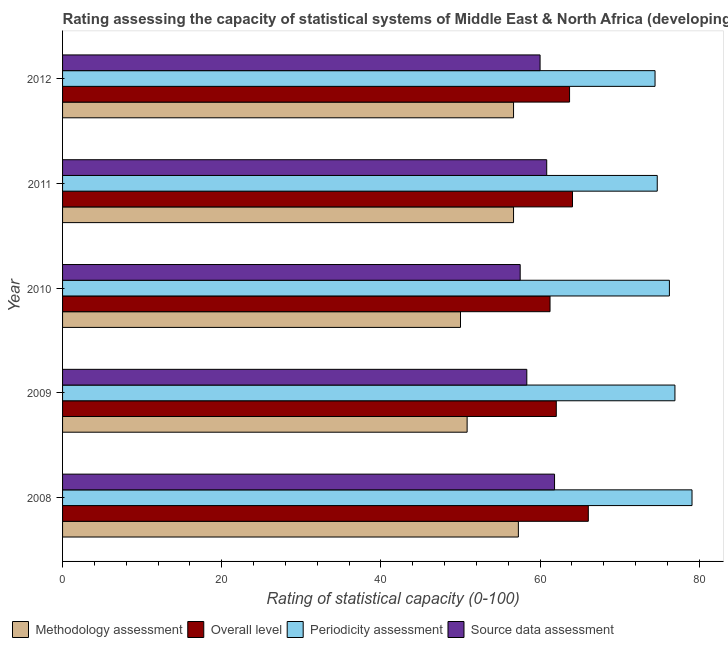How many different coloured bars are there?
Your answer should be compact. 4. How many groups of bars are there?
Make the answer very short. 5. Are the number of bars on each tick of the Y-axis equal?
Your response must be concise. Yes. How many bars are there on the 5th tick from the bottom?
Offer a very short reply. 4. What is the periodicity assessment rating in 2009?
Provide a short and direct response. 76.94. Across all years, what is the maximum periodicity assessment rating?
Your answer should be compact. 79.09. Across all years, what is the minimum periodicity assessment rating?
Provide a succinct answer. 74.44. In which year was the periodicity assessment rating minimum?
Your response must be concise. 2012. What is the total periodicity assessment rating in the graph?
Offer a terse response. 381.45. What is the difference between the source data assessment rating in 2008 and that in 2009?
Your response must be concise. 3.48. What is the difference between the source data assessment rating in 2010 and the methodology assessment rating in 2009?
Provide a short and direct response. 6.67. What is the average overall level rating per year?
Provide a short and direct response. 63.42. In the year 2011, what is the difference between the overall level rating and source data assessment rating?
Your response must be concise. 3.24. What is the ratio of the periodicity assessment rating in 2010 to that in 2012?
Ensure brevity in your answer.  1.02. Is the difference between the overall level rating in 2008 and 2009 greater than the difference between the source data assessment rating in 2008 and 2009?
Your answer should be compact. Yes. What is the difference between the highest and the second highest overall level rating?
Provide a succinct answer. 1.99. What is the difference between the highest and the lowest methodology assessment rating?
Provide a short and direct response. 7.27. In how many years, is the overall level rating greater than the average overall level rating taken over all years?
Offer a very short reply. 3. Is the sum of the source data assessment rating in 2008 and 2009 greater than the maximum overall level rating across all years?
Your answer should be compact. Yes. Is it the case that in every year, the sum of the overall level rating and source data assessment rating is greater than the sum of periodicity assessment rating and methodology assessment rating?
Provide a short and direct response. No. What does the 1st bar from the top in 2008 represents?
Ensure brevity in your answer.  Source data assessment. What does the 4th bar from the bottom in 2008 represents?
Ensure brevity in your answer.  Source data assessment. Are all the bars in the graph horizontal?
Give a very brief answer. Yes. How many years are there in the graph?
Your answer should be very brief. 5. Are the values on the major ticks of X-axis written in scientific E-notation?
Ensure brevity in your answer.  No. Does the graph contain any zero values?
Offer a very short reply. No. Does the graph contain grids?
Keep it short and to the point. No. Where does the legend appear in the graph?
Your answer should be very brief. Bottom left. How many legend labels are there?
Keep it short and to the point. 4. How are the legend labels stacked?
Your answer should be very brief. Horizontal. What is the title of the graph?
Make the answer very short. Rating assessing the capacity of statistical systems of Middle East & North Africa (developing only). What is the label or title of the X-axis?
Give a very brief answer. Rating of statistical capacity (0-100). What is the label or title of the Y-axis?
Offer a terse response. Year. What is the Rating of statistical capacity (0-100) in Methodology assessment in 2008?
Provide a short and direct response. 57.27. What is the Rating of statistical capacity (0-100) in Overall level in 2008?
Your response must be concise. 66.06. What is the Rating of statistical capacity (0-100) of Periodicity assessment in 2008?
Your answer should be very brief. 79.09. What is the Rating of statistical capacity (0-100) of Source data assessment in 2008?
Offer a very short reply. 61.82. What is the Rating of statistical capacity (0-100) in Methodology assessment in 2009?
Your answer should be compact. 50.83. What is the Rating of statistical capacity (0-100) of Overall level in 2009?
Your answer should be compact. 62.04. What is the Rating of statistical capacity (0-100) of Periodicity assessment in 2009?
Give a very brief answer. 76.94. What is the Rating of statistical capacity (0-100) in Source data assessment in 2009?
Offer a terse response. 58.33. What is the Rating of statistical capacity (0-100) in Methodology assessment in 2010?
Ensure brevity in your answer.  50. What is the Rating of statistical capacity (0-100) in Overall level in 2010?
Your response must be concise. 61.25. What is the Rating of statistical capacity (0-100) in Periodicity assessment in 2010?
Offer a terse response. 76.25. What is the Rating of statistical capacity (0-100) in Source data assessment in 2010?
Your answer should be compact. 57.5. What is the Rating of statistical capacity (0-100) in Methodology assessment in 2011?
Your answer should be compact. 56.67. What is the Rating of statistical capacity (0-100) in Overall level in 2011?
Your response must be concise. 64.07. What is the Rating of statistical capacity (0-100) in Periodicity assessment in 2011?
Keep it short and to the point. 74.72. What is the Rating of statistical capacity (0-100) in Source data assessment in 2011?
Give a very brief answer. 60.83. What is the Rating of statistical capacity (0-100) of Methodology assessment in 2012?
Provide a succinct answer. 56.67. What is the Rating of statistical capacity (0-100) in Overall level in 2012?
Your answer should be very brief. 63.7. What is the Rating of statistical capacity (0-100) of Periodicity assessment in 2012?
Ensure brevity in your answer.  74.44. What is the Rating of statistical capacity (0-100) of Source data assessment in 2012?
Provide a succinct answer. 60. Across all years, what is the maximum Rating of statistical capacity (0-100) of Methodology assessment?
Make the answer very short. 57.27. Across all years, what is the maximum Rating of statistical capacity (0-100) of Overall level?
Ensure brevity in your answer.  66.06. Across all years, what is the maximum Rating of statistical capacity (0-100) in Periodicity assessment?
Give a very brief answer. 79.09. Across all years, what is the maximum Rating of statistical capacity (0-100) of Source data assessment?
Provide a short and direct response. 61.82. Across all years, what is the minimum Rating of statistical capacity (0-100) of Methodology assessment?
Provide a succinct answer. 50. Across all years, what is the minimum Rating of statistical capacity (0-100) of Overall level?
Provide a succinct answer. 61.25. Across all years, what is the minimum Rating of statistical capacity (0-100) of Periodicity assessment?
Ensure brevity in your answer.  74.44. Across all years, what is the minimum Rating of statistical capacity (0-100) in Source data assessment?
Your answer should be very brief. 57.5. What is the total Rating of statistical capacity (0-100) of Methodology assessment in the graph?
Provide a succinct answer. 271.44. What is the total Rating of statistical capacity (0-100) of Overall level in the graph?
Make the answer very short. 317.13. What is the total Rating of statistical capacity (0-100) in Periodicity assessment in the graph?
Your answer should be compact. 381.45. What is the total Rating of statistical capacity (0-100) of Source data assessment in the graph?
Your response must be concise. 298.48. What is the difference between the Rating of statistical capacity (0-100) in Methodology assessment in 2008 and that in 2009?
Your answer should be very brief. 6.44. What is the difference between the Rating of statistical capacity (0-100) in Overall level in 2008 and that in 2009?
Provide a succinct answer. 4.02. What is the difference between the Rating of statistical capacity (0-100) of Periodicity assessment in 2008 and that in 2009?
Give a very brief answer. 2.15. What is the difference between the Rating of statistical capacity (0-100) in Source data assessment in 2008 and that in 2009?
Keep it short and to the point. 3.48. What is the difference between the Rating of statistical capacity (0-100) in Methodology assessment in 2008 and that in 2010?
Give a very brief answer. 7.27. What is the difference between the Rating of statistical capacity (0-100) in Overall level in 2008 and that in 2010?
Keep it short and to the point. 4.81. What is the difference between the Rating of statistical capacity (0-100) of Periodicity assessment in 2008 and that in 2010?
Provide a succinct answer. 2.84. What is the difference between the Rating of statistical capacity (0-100) in Source data assessment in 2008 and that in 2010?
Provide a succinct answer. 4.32. What is the difference between the Rating of statistical capacity (0-100) in Methodology assessment in 2008 and that in 2011?
Provide a succinct answer. 0.61. What is the difference between the Rating of statistical capacity (0-100) of Overall level in 2008 and that in 2011?
Offer a terse response. 1.99. What is the difference between the Rating of statistical capacity (0-100) of Periodicity assessment in 2008 and that in 2011?
Provide a short and direct response. 4.37. What is the difference between the Rating of statistical capacity (0-100) in Methodology assessment in 2008 and that in 2012?
Keep it short and to the point. 0.61. What is the difference between the Rating of statistical capacity (0-100) of Overall level in 2008 and that in 2012?
Keep it short and to the point. 2.36. What is the difference between the Rating of statistical capacity (0-100) of Periodicity assessment in 2008 and that in 2012?
Give a very brief answer. 4.65. What is the difference between the Rating of statistical capacity (0-100) of Source data assessment in 2008 and that in 2012?
Keep it short and to the point. 1.82. What is the difference between the Rating of statistical capacity (0-100) of Methodology assessment in 2009 and that in 2010?
Your answer should be compact. 0.83. What is the difference between the Rating of statistical capacity (0-100) in Overall level in 2009 and that in 2010?
Provide a succinct answer. 0.79. What is the difference between the Rating of statistical capacity (0-100) in Periodicity assessment in 2009 and that in 2010?
Provide a short and direct response. 0.69. What is the difference between the Rating of statistical capacity (0-100) of Methodology assessment in 2009 and that in 2011?
Provide a succinct answer. -5.83. What is the difference between the Rating of statistical capacity (0-100) in Overall level in 2009 and that in 2011?
Offer a terse response. -2.04. What is the difference between the Rating of statistical capacity (0-100) of Periodicity assessment in 2009 and that in 2011?
Your answer should be compact. 2.22. What is the difference between the Rating of statistical capacity (0-100) in Source data assessment in 2009 and that in 2011?
Offer a terse response. -2.5. What is the difference between the Rating of statistical capacity (0-100) in Methodology assessment in 2009 and that in 2012?
Give a very brief answer. -5.83. What is the difference between the Rating of statistical capacity (0-100) of Overall level in 2009 and that in 2012?
Your answer should be very brief. -1.67. What is the difference between the Rating of statistical capacity (0-100) in Source data assessment in 2009 and that in 2012?
Give a very brief answer. -1.67. What is the difference between the Rating of statistical capacity (0-100) in Methodology assessment in 2010 and that in 2011?
Offer a very short reply. -6.67. What is the difference between the Rating of statistical capacity (0-100) of Overall level in 2010 and that in 2011?
Keep it short and to the point. -2.82. What is the difference between the Rating of statistical capacity (0-100) in Periodicity assessment in 2010 and that in 2011?
Make the answer very short. 1.53. What is the difference between the Rating of statistical capacity (0-100) of Methodology assessment in 2010 and that in 2012?
Your answer should be very brief. -6.67. What is the difference between the Rating of statistical capacity (0-100) in Overall level in 2010 and that in 2012?
Keep it short and to the point. -2.45. What is the difference between the Rating of statistical capacity (0-100) in Periodicity assessment in 2010 and that in 2012?
Offer a very short reply. 1.81. What is the difference between the Rating of statistical capacity (0-100) of Source data assessment in 2010 and that in 2012?
Your response must be concise. -2.5. What is the difference between the Rating of statistical capacity (0-100) of Overall level in 2011 and that in 2012?
Give a very brief answer. 0.37. What is the difference between the Rating of statistical capacity (0-100) of Periodicity assessment in 2011 and that in 2012?
Ensure brevity in your answer.  0.28. What is the difference between the Rating of statistical capacity (0-100) in Methodology assessment in 2008 and the Rating of statistical capacity (0-100) in Overall level in 2009?
Your answer should be very brief. -4.76. What is the difference between the Rating of statistical capacity (0-100) in Methodology assessment in 2008 and the Rating of statistical capacity (0-100) in Periodicity assessment in 2009?
Make the answer very short. -19.67. What is the difference between the Rating of statistical capacity (0-100) of Methodology assessment in 2008 and the Rating of statistical capacity (0-100) of Source data assessment in 2009?
Provide a short and direct response. -1.06. What is the difference between the Rating of statistical capacity (0-100) in Overall level in 2008 and the Rating of statistical capacity (0-100) in Periodicity assessment in 2009?
Offer a terse response. -10.88. What is the difference between the Rating of statistical capacity (0-100) of Overall level in 2008 and the Rating of statistical capacity (0-100) of Source data assessment in 2009?
Ensure brevity in your answer.  7.73. What is the difference between the Rating of statistical capacity (0-100) in Periodicity assessment in 2008 and the Rating of statistical capacity (0-100) in Source data assessment in 2009?
Make the answer very short. 20.76. What is the difference between the Rating of statistical capacity (0-100) of Methodology assessment in 2008 and the Rating of statistical capacity (0-100) of Overall level in 2010?
Offer a terse response. -3.98. What is the difference between the Rating of statistical capacity (0-100) in Methodology assessment in 2008 and the Rating of statistical capacity (0-100) in Periodicity assessment in 2010?
Your response must be concise. -18.98. What is the difference between the Rating of statistical capacity (0-100) in Methodology assessment in 2008 and the Rating of statistical capacity (0-100) in Source data assessment in 2010?
Offer a very short reply. -0.23. What is the difference between the Rating of statistical capacity (0-100) of Overall level in 2008 and the Rating of statistical capacity (0-100) of Periodicity assessment in 2010?
Your response must be concise. -10.19. What is the difference between the Rating of statistical capacity (0-100) in Overall level in 2008 and the Rating of statistical capacity (0-100) in Source data assessment in 2010?
Make the answer very short. 8.56. What is the difference between the Rating of statistical capacity (0-100) in Periodicity assessment in 2008 and the Rating of statistical capacity (0-100) in Source data assessment in 2010?
Keep it short and to the point. 21.59. What is the difference between the Rating of statistical capacity (0-100) in Methodology assessment in 2008 and the Rating of statistical capacity (0-100) in Overall level in 2011?
Give a very brief answer. -6.8. What is the difference between the Rating of statistical capacity (0-100) in Methodology assessment in 2008 and the Rating of statistical capacity (0-100) in Periodicity assessment in 2011?
Give a very brief answer. -17.45. What is the difference between the Rating of statistical capacity (0-100) in Methodology assessment in 2008 and the Rating of statistical capacity (0-100) in Source data assessment in 2011?
Ensure brevity in your answer.  -3.56. What is the difference between the Rating of statistical capacity (0-100) of Overall level in 2008 and the Rating of statistical capacity (0-100) of Periodicity assessment in 2011?
Keep it short and to the point. -8.66. What is the difference between the Rating of statistical capacity (0-100) in Overall level in 2008 and the Rating of statistical capacity (0-100) in Source data assessment in 2011?
Your answer should be compact. 5.23. What is the difference between the Rating of statistical capacity (0-100) of Periodicity assessment in 2008 and the Rating of statistical capacity (0-100) of Source data assessment in 2011?
Your response must be concise. 18.26. What is the difference between the Rating of statistical capacity (0-100) of Methodology assessment in 2008 and the Rating of statistical capacity (0-100) of Overall level in 2012?
Offer a terse response. -6.43. What is the difference between the Rating of statistical capacity (0-100) in Methodology assessment in 2008 and the Rating of statistical capacity (0-100) in Periodicity assessment in 2012?
Your response must be concise. -17.17. What is the difference between the Rating of statistical capacity (0-100) in Methodology assessment in 2008 and the Rating of statistical capacity (0-100) in Source data assessment in 2012?
Your response must be concise. -2.73. What is the difference between the Rating of statistical capacity (0-100) in Overall level in 2008 and the Rating of statistical capacity (0-100) in Periodicity assessment in 2012?
Provide a succinct answer. -8.38. What is the difference between the Rating of statistical capacity (0-100) of Overall level in 2008 and the Rating of statistical capacity (0-100) of Source data assessment in 2012?
Your answer should be very brief. 6.06. What is the difference between the Rating of statistical capacity (0-100) of Periodicity assessment in 2008 and the Rating of statistical capacity (0-100) of Source data assessment in 2012?
Your response must be concise. 19.09. What is the difference between the Rating of statistical capacity (0-100) of Methodology assessment in 2009 and the Rating of statistical capacity (0-100) of Overall level in 2010?
Give a very brief answer. -10.42. What is the difference between the Rating of statistical capacity (0-100) of Methodology assessment in 2009 and the Rating of statistical capacity (0-100) of Periodicity assessment in 2010?
Your response must be concise. -25.42. What is the difference between the Rating of statistical capacity (0-100) in Methodology assessment in 2009 and the Rating of statistical capacity (0-100) in Source data assessment in 2010?
Ensure brevity in your answer.  -6.67. What is the difference between the Rating of statistical capacity (0-100) in Overall level in 2009 and the Rating of statistical capacity (0-100) in Periodicity assessment in 2010?
Your answer should be compact. -14.21. What is the difference between the Rating of statistical capacity (0-100) in Overall level in 2009 and the Rating of statistical capacity (0-100) in Source data assessment in 2010?
Give a very brief answer. 4.54. What is the difference between the Rating of statistical capacity (0-100) in Periodicity assessment in 2009 and the Rating of statistical capacity (0-100) in Source data assessment in 2010?
Your answer should be very brief. 19.44. What is the difference between the Rating of statistical capacity (0-100) of Methodology assessment in 2009 and the Rating of statistical capacity (0-100) of Overall level in 2011?
Keep it short and to the point. -13.24. What is the difference between the Rating of statistical capacity (0-100) in Methodology assessment in 2009 and the Rating of statistical capacity (0-100) in Periodicity assessment in 2011?
Your answer should be very brief. -23.89. What is the difference between the Rating of statistical capacity (0-100) of Methodology assessment in 2009 and the Rating of statistical capacity (0-100) of Source data assessment in 2011?
Offer a terse response. -10. What is the difference between the Rating of statistical capacity (0-100) of Overall level in 2009 and the Rating of statistical capacity (0-100) of Periodicity assessment in 2011?
Your response must be concise. -12.69. What is the difference between the Rating of statistical capacity (0-100) of Overall level in 2009 and the Rating of statistical capacity (0-100) of Source data assessment in 2011?
Ensure brevity in your answer.  1.2. What is the difference between the Rating of statistical capacity (0-100) of Periodicity assessment in 2009 and the Rating of statistical capacity (0-100) of Source data assessment in 2011?
Ensure brevity in your answer.  16.11. What is the difference between the Rating of statistical capacity (0-100) of Methodology assessment in 2009 and the Rating of statistical capacity (0-100) of Overall level in 2012?
Provide a short and direct response. -12.87. What is the difference between the Rating of statistical capacity (0-100) in Methodology assessment in 2009 and the Rating of statistical capacity (0-100) in Periodicity assessment in 2012?
Make the answer very short. -23.61. What is the difference between the Rating of statistical capacity (0-100) in Methodology assessment in 2009 and the Rating of statistical capacity (0-100) in Source data assessment in 2012?
Provide a short and direct response. -9.17. What is the difference between the Rating of statistical capacity (0-100) of Overall level in 2009 and the Rating of statistical capacity (0-100) of Periodicity assessment in 2012?
Make the answer very short. -12.41. What is the difference between the Rating of statistical capacity (0-100) in Overall level in 2009 and the Rating of statistical capacity (0-100) in Source data assessment in 2012?
Your response must be concise. 2.04. What is the difference between the Rating of statistical capacity (0-100) in Periodicity assessment in 2009 and the Rating of statistical capacity (0-100) in Source data assessment in 2012?
Your response must be concise. 16.94. What is the difference between the Rating of statistical capacity (0-100) of Methodology assessment in 2010 and the Rating of statistical capacity (0-100) of Overall level in 2011?
Your answer should be very brief. -14.07. What is the difference between the Rating of statistical capacity (0-100) in Methodology assessment in 2010 and the Rating of statistical capacity (0-100) in Periodicity assessment in 2011?
Your answer should be very brief. -24.72. What is the difference between the Rating of statistical capacity (0-100) in Methodology assessment in 2010 and the Rating of statistical capacity (0-100) in Source data assessment in 2011?
Your answer should be compact. -10.83. What is the difference between the Rating of statistical capacity (0-100) of Overall level in 2010 and the Rating of statistical capacity (0-100) of Periodicity assessment in 2011?
Your answer should be very brief. -13.47. What is the difference between the Rating of statistical capacity (0-100) of Overall level in 2010 and the Rating of statistical capacity (0-100) of Source data assessment in 2011?
Offer a very short reply. 0.42. What is the difference between the Rating of statistical capacity (0-100) of Periodicity assessment in 2010 and the Rating of statistical capacity (0-100) of Source data assessment in 2011?
Your response must be concise. 15.42. What is the difference between the Rating of statistical capacity (0-100) in Methodology assessment in 2010 and the Rating of statistical capacity (0-100) in Overall level in 2012?
Provide a succinct answer. -13.7. What is the difference between the Rating of statistical capacity (0-100) in Methodology assessment in 2010 and the Rating of statistical capacity (0-100) in Periodicity assessment in 2012?
Provide a succinct answer. -24.44. What is the difference between the Rating of statistical capacity (0-100) of Methodology assessment in 2010 and the Rating of statistical capacity (0-100) of Source data assessment in 2012?
Keep it short and to the point. -10. What is the difference between the Rating of statistical capacity (0-100) in Overall level in 2010 and the Rating of statistical capacity (0-100) in Periodicity assessment in 2012?
Offer a terse response. -13.19. What is the difference between the Rating of statistical capacity (0-100) in Periodicity assessment in 2010 and the Rating of statistical capacity (0-100) in Source data assessment in 2012?
Offer a terse response. 16.25. What is the difference between the Rating of statistical capacity (0-100) in Methodology assessment in 2011 and the Rating of statistical capacity (0-100) in Overall level in 2012?
Ensure brevity in your answer.  -7.04. What is the difference between the Rating of statistical capacity (0-100) in Methodology assessment in 2011 and the Rating of statistical capacity (0-100) in Periodicity assessment in 2012?
Provide a short and direct response. -17.78. What is the difference between the Rating of statistical capacity (0-100) in Methodology assessment in 2011 and the Rating of statistical capacity (0-100) in Source data assessment in 2012?
Ensure brevity in your answer.  -3.33. What is the difference between the Rating of statistical capacity (0-100) of Overall level in 2011 and the Rating of statistical capacity (0-100) of Periodicity assessment in 2012?
Ensure brevity in your answer.  -10.37. What is the difference between the Rating of statistical capacity (0-100) of Overall level in 2011 and the Rating of statistical capacity (0-100) of Source data assessment in 2012?
Provide a succinct answer. 4.07. What is the difference between the Rating of statistical capacity (0-100) in Periodicity assessment in 2011 and the Rating of statistical capacity (0-100) in Source data assessment in 2012?
Keep it short and to the point. 14.72. What is the average Rating of statistical capacity (0-100) of Methodology assessment per year?
Your response must be concise. 54.29. What is the average Rating of statistical capacity (0-100) of Overall level per year?
Make the answer very short. 63.43. What is the average Rating of statistical capacity (0-100) in Periodicity assessment per year?
Give a very brief answer. 76.29. What is the average Rating of statistical capacity (0-100) in Source data assessment per year?
Provide a succinct answer. 59.7. In the year 2008, what is the difference between the Rating of statistical capacity (0-100) of Methodology assessment and Rating of statistical capacity (0-100) of Overall level?
Your answer should be compact. -8.79. In the year 2008, what is the difference between the Rating of statistical capacity (0-100) of Methodology assessment and Rating of statistical capacity (0-100) of Periodicity assessment?
Keep it short and to the point. -21.82. In the year 2008, what is the difference between the Rating of statistical capacity (0-100) of Methodology assessment and Rating of statistical capacity (0-100) of Source data assessment?
Your response must be concise. -4.55. In the year 2008, what is the difference between the Rating of statistical capacity (0-100) in Overall level and Rating of statistical capacity (0-100) in Periodicity assessment?
Offer a very short reply. -13.03. In the year 2008, what is the difference between the Rating of statistical capacity (0-100) in Overall level and Rating of statistical capacity (0-100) in Source data assessment?
Provide a succinct answer. 4.24. In the year 2008, what is the difference between the Rating of statistical capacity (0-100) in Periodicity assessment and Rating of statistical capacity (0-100) in Source data assessment?
Give a very brief answer. 17.27. In the year 2009, what is the difference between the Rating of statistical capacity (0-100) in Methodology assessment and Rating of statistical capacity (0-100) in Overall level?
Give a very brief answer. -11.2. In the year 2009, what is the difference between the Rating of statistical capacity (0-100) of Methodology assessment and Rating of statistical capacity (0-100) of Periodicity assessment?
Give a very brief answer. -26.11. In the year 2009, what is the difference between the Rating of statistical capacity (0-100) in Methodology assessment and Rating of statistical capacity (0-100) in Source data assessment?
Your answer should be compact. -7.5. In the year 2009, what is the difference between the Rating of statistical capacity (0-100) of Overall level and Rating of statistical capacity (0-100) of Periodicity assessment?
Ensure brevity in your answer.  -14.91. In the year 2009, what is the difference between the Rating of statistical capacity (0-100) in Overall level and Rating of statistical capacity (0-100) in Source data assessment?
Your answer should be very brief. 3.7. In the year 2009, what is the difference between the Rating of statistical capacity (0-100) of Periodicity assessment and Rating of statistical capacity (0-100) of Source data assessment?
Your answer should be compact. 18.61. In the year 2010, what is the difference between the Rating of statistical capacity (0-100) of Methodology assessment and Rating of statistical capacity (0-100) of Overall level?
Keep it short and to the point. -11.25. In the year 2010, what is the difference between the Rating of statistical capacity (0-100) of Methodology assessment and Rating of statistical capacity (0-100) of Periodicity assessment?
Provide a short and direct response. -26.25. In the year 2010, what is the difference between the Rating of statistical capacity (0-100) of Overall level and Rating of statistical capacity (0-100) of Source data assessment?
Keep it short and to the point. 3.75. In the year 2010, what is the difference between the Rating of statistical capacity (0-100) of Periodicity assessment and Rating of statistical capacity (0-100) of Source data assessment?
Give a very brief answer. 18.75. In the year 2011, what is the difference between the Rating of statistical capacity (0-100) of Methodology assessment and Rating of statistical capacity (0-100) of Overall level?
Your response must be concise. -7.41. In the year 2011, what is the difference between the Rating of statistical capacity (0-100) of Methodology assessment and Rating of statistical capacity (0-100) of Periodicity assessment?
Your answer should be compact. -18.06. In the year 2011, what is the difference between the Rating of statistical capacity (0-100) of Methodology assessment and Rating of statistical capacity (0-100) of Source data assessment?
Your answer should be very brief. -4.17. In the year 2011, what is the difference between the Rating of statistical capacity (0-100) of Overall level and Rating of statistical capacity (0-100) of Periodicity assessment?
Your answer should be very brief. -10.65. In the year 2011, what is the difference between the Rating of statistical capacity (0-100) in Overall level and Rating of statistical capacity (0-100) in Source data assessment?
Make the answer very short. 3.24. In the year 2011, what is the difference between the Rating of statistical capacity (0-100) in Periodicity assessment and Rating of statistical capacity (0-100) in Source data assessment?
Offer a very short reply. 13.89. In the year 2012, what is the difference between the Rating of statistical capacity (0-100) in Methodology assessment and Rating of statistical capacity (0-100) in Overall level?
Keep it short and to the point. -7.04. In the year 2012, what is the difference between the Rating of statistical capacity (0-100) of Methodology assessment and Rating of statistical capacity (0-100) of Periodicity assessment?
Offer a terse response. -17.78. In the year 2012, what is the difference between the Rating of statistical capacity (0-100) of Overall level and Rating of statistical capacity (0-100) of Periodicity assessment?
Offer a very short reply. -10.74. In the year 2012, what is the difference between the Rating of statistical capacity (0-100) in Overall level and Rating of statistical capacity (0-100) in Source data assessment?
Keep it short and to the point. 3.7. In the year 2012, what is the difference between the Rating of statistical capacity (0-100) of Periodicity assessment and Rating of statistical capacity (0-100) of Source data assessment?
Offer a terse response. 14.44. What is the ratio of the Rating of statistical capacity (0-100) of Methodology assessment in 2008 to that in 2009?
Offer a terse response. 1.13. What is the ratio of the Rating of statistical capacity (0-100) in Overall level in 2008 to that in 2009?
Provide a succinct answer. 1.06. What is the ratio of the Rating of statistical capacity (0-100) of Periodicity assessment in 2008 to that in 2009?
Provide a short and direct response. 1.03. What is the ratio of the Rating of statistical capacity (0-100) of Source data assessment in 2008 to that in 2009?
Offer a terse response. 1.06. What is the ratio of the Rating of statistical capacity (0-100) of Methodology assessment in 2008 to that in 2010?
Offer a terse response. 1.15. What is the ratio of the Rating of statistical capacity (0-100) of Overall level in 2008 to that in 2010?
Provide a short and direct response. 1.08. What is the ratio of the Rating of statistical capacity (0-100) in Periodicity assessment in 2008 to that in 2010?
Ensure brevity in your answer.  1.04. What is the ratio of the Rating of statistical capacity (0-100) of Source data assessment in 2008 to that in 2010?
Your response must be concise. 1.08. What is the ratio of the Rating of statistical capacity (0-100) in Methodology assessment in 2008 to that in 2011?
Your answer should be very brief. 1.01. What is the ratio of the Rating of statistical capacity (0-100) in Overall level in 2008 to that in 2011?
Provide a short and direct response. 1.03. What is the ratio of the Rating of statistical capacity (0-100) of Periodicity assessment in 2008 to that in 2011?
Ensure brevity in your answer.  1.06. What is the ratio of the Rating of statistical capacity (0-100) of Source data assessment in 2008 to that in 2011?
Give a very brief answer. 1.02. What is the ratio of the Rating of statistical capacity (0-100) of Methodology assessment in 2008 to that in 2012?
Provide a succinct answer. 1.01. What is the ratio of the Rating of statistical capacity (0-100) of Periodicity assessment in 2008 to that in 2012?
Offer a very short reply. 1.06. What is the ratio of the Rating of statistical capacity (0-100) in Source data assessment in 2008 to that in 2012?
Your answer should be very brief. 1.03. What is the ratio of the Rating of statistical capacity (0-100) in Methodology assessment in 2009 to that in 2010?
Your response must be concise. 1.02. What is the ratio of the Rating of statistical capacity (0-100) in Overall level in 2009 to that in 2010?
Make the answer very short. 1.01. What is the ratio of the Rating of statistical capacity (0-100) in Periodicity assessment in 2009 to that in 2010?
Your response must be concise. 1.01. What is the ratio of the Rating of statistical capacity (0-100) of Source data assessment in 2009 to that in 2010?
Offer a terse response. 1.01. What is the ratio of the Rating of statistical capacity (0-100) in Methodology assessment in 2009 to that in 2011?
Your answer should be compact. 0.9. What is the ratio of the Rating of statistical capacity (0-100) of Overall level in 2009 to that in 2011?
Provide a succinct answer. 0.97. What is the ratio of the Rating of statistical capacity (0-100) of Periodicity assessment in 2009 to that in 2011?
Provide a succinct answer. 1.03. What is the ratio of the Rating of statistical capacity (0-100) of Source data assessment in 2009 to that in 2011?
Keep it short and to the point. 0.96. What is the ratio of the Rating of statistical capacity (0-100) of Methodology assessment in 2009 to that in 2012?
Offer a terse response. 0.9. What is the ratio of the Rating of statistical capacity (0-100) of Overall level in 2009 to that in 2012?
Offer a very short reply. 0.97. What is the ratio of the Rating of statistical capacity (0-100) of Periodicity assessment in 2009 to that in 2012?
Keep it short and to the point. 1.03. What is the ratio of the Rating of statistical capacity (0-100) of Source data assessment in 2009 to that in 2012?
Give a very brief answer. 0.97. What is the ratio of the Rating of statistical capacity (0-100) of Methodology assessment in 2010 to that in 2011?
Your answer should be compact. 0.88. What is the ratio of the Rating of statistical capacity (0-100) in Overall level in 2010 to that in 2011?
Give a very brief answer. 0.96. What is the ratio of the Rating of statistical capacity (0-100) of Periodicity assessment in 2010 to that in 2011?
Keep it short and to the point. 1.02. What is the ratio of the Rating of statistical capacity (0-100) in Source data assessment in 2010 to that in 2011?
Offer a terse response. 0.95. What is the ratio of the Rating of statistical capacity (0-100) in Methodology assessment in 2010 to that in 2012?
Make the answer very short. 0.88. What is the ratio of the Rating of statistical capacity (0-100) of Overall level in 2010 to that in 2012?
Provide a succinct answer. 0.96. What is the ratio of the Rating of statistical capacity (0-100) in Periodicity assessment in 2010 to that in 2012?
Make the answer very short. 1.02. What is the ratio of the Rating of statistical capacity (0-100) in Overall level in 2011 to that in 2012?
Provide a succinct answer. 1.01. What is the ratio of the Rating of statistical capacity (0-100) of Periodicity assessment in 2011 to that in 2012?
Keep it short and to the point. 1. What is the ratio of the Rating of statistical capacity (0-100) of Source data assessment in 2011 to that in 2012?
Your answer should be compact. 1.01. What is the difference between the highest and the second highest Rating of statistical capacity (0-100) of Methodology assessment?
Offer a very short reply. 0.61. What is the difference between the highest and the second highest Rating of statistical capacity (0-100) of Overall level?
Offer a very short reply. 1.99. What is the difference between the highest and the second highest Rating of statistical capacity (0-100) in Periodicity assessment?
Offer a terse response. 2.15. What is the difference between the highest and the lowest Rating of statistical capacity (0-100) in Methodology assessment?
Your answer should be compact. 7.27. What is the difference between the highest and the lowest Rating of statistical capacity (0-100) of Overall level?
Keep it short and to the point. 4.81. What is the difference between the highest and the lowest Rating of statistical capacity (0-100) in Periodicity assessment?
Provide a short and direct response. 4.65. What is the difference between the highest and the lowest Rating of statistical capacity (0-100) in Source data assessment?
Ensure brevity in your answer.  4.32. 